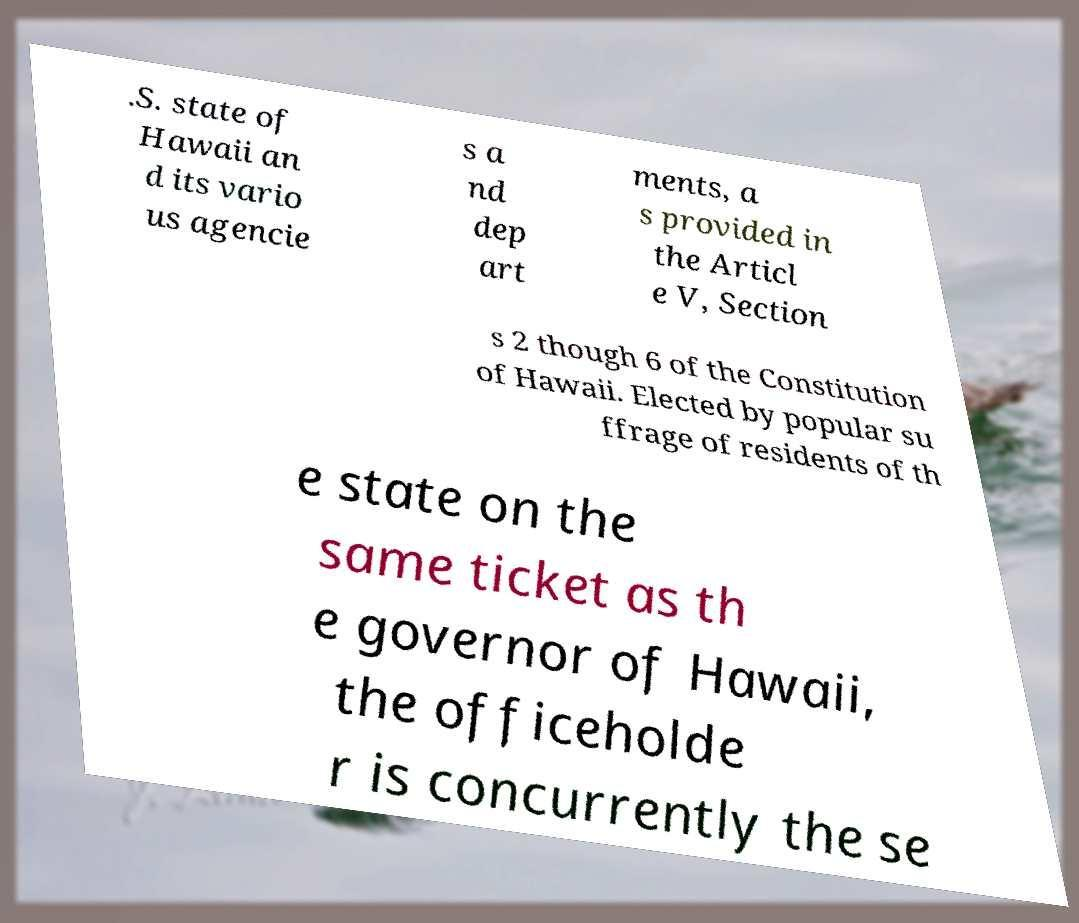For documentation purposes, I need the text within this image transcribed. Could you provide that? .S. state of Hawaii an d its vario us agencie s a nd dep art ments, a s provided in the Articl e V, Section s 2 though 6 of the Constitution of Hawaii. Elected by popular su ffrage of residents of th e state on the same ticket as th e governor of Hawaii, the officeholde r is concurrently the se 